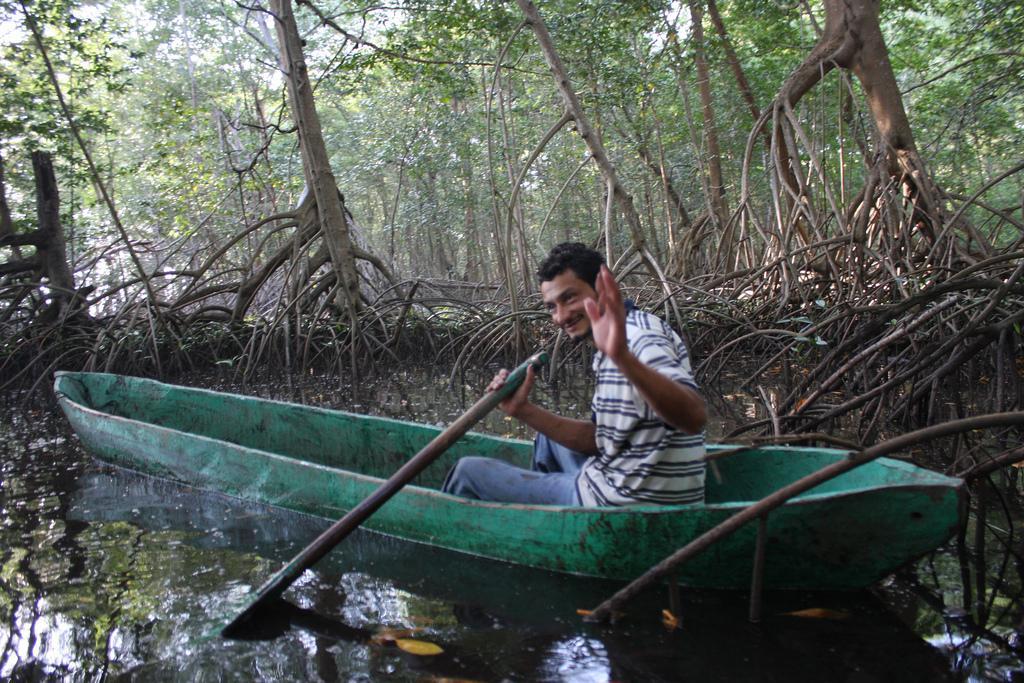In one or two sentences, can you explain what this image depicts? In this image we can see a person sitting in a boat holding stick in his hand. In the background, we can see a group of trees, leaves and sky. 